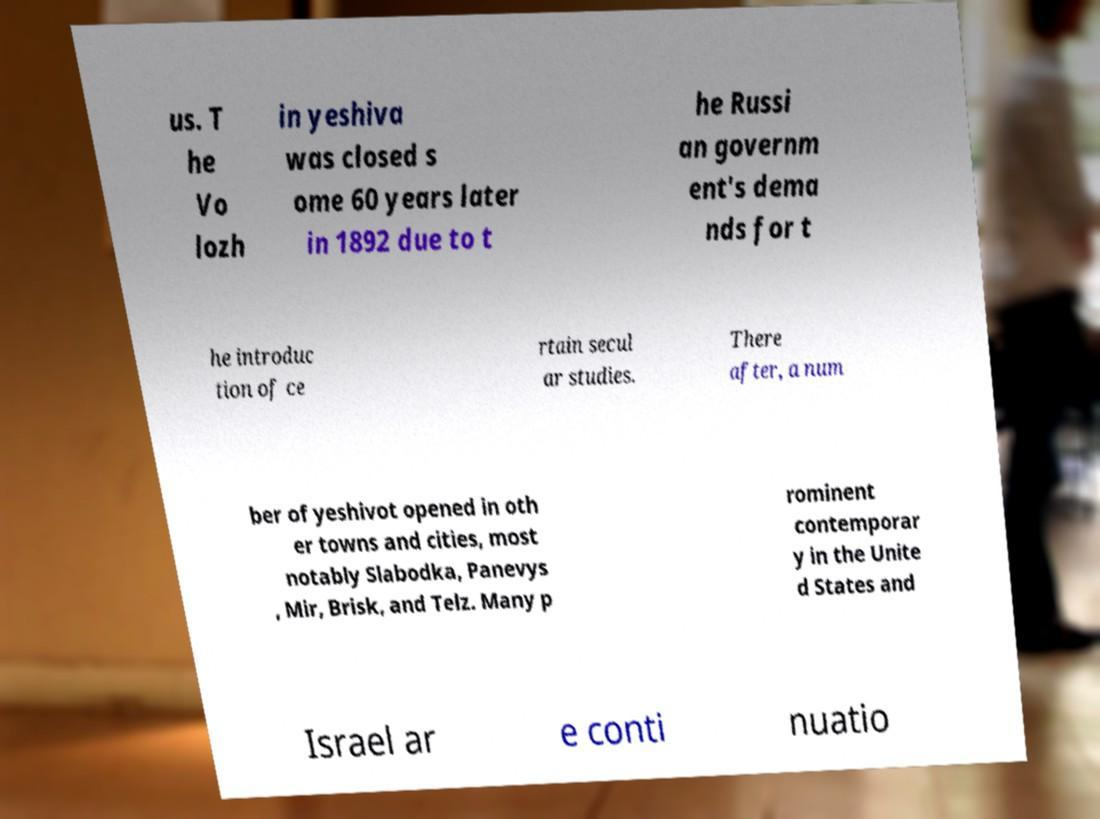Could you assist in decoding the text presented in this image and type it out clearly? us. T he Vo lozh in yeshiva was closed s ome 60 years later in 1892 due to t he Russi an governm ent's dema nds for t he introduc tion of ce rtain secul ar studies. There after, a num ber of yeshivot opened in oth er towns and cities, most notably Slabodka, Panevys , Mir, Brisk, and Telz. Many p rominent contemporar y in the Unite d States and Israel ar e conti nuatio 